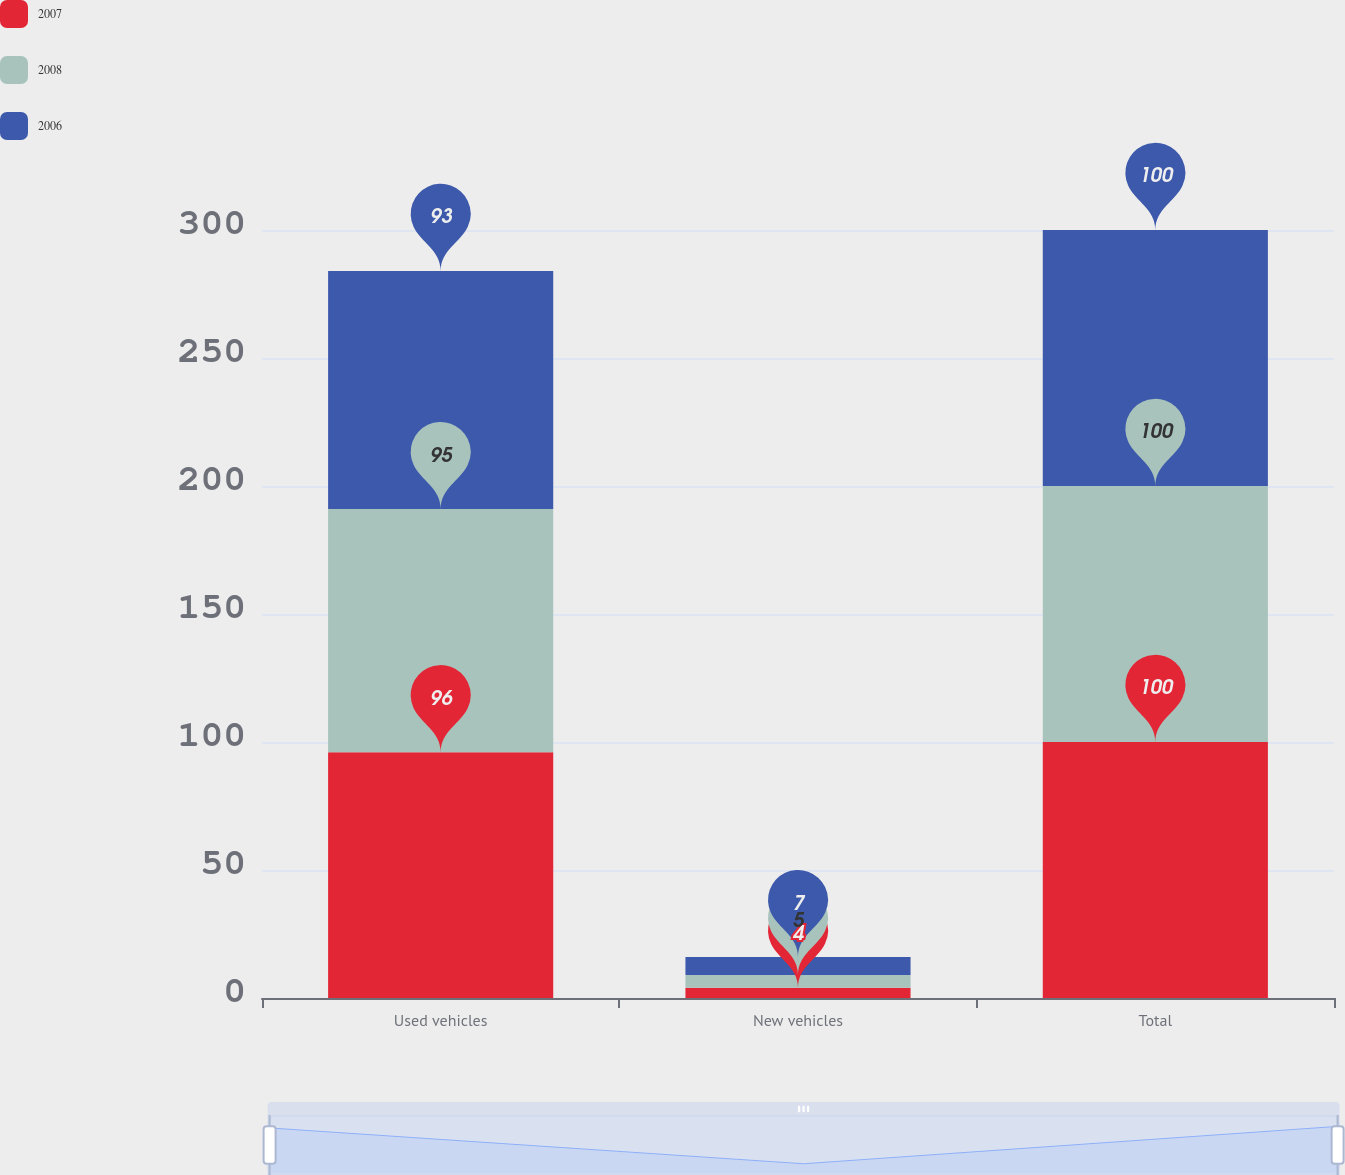Convert chart. <chart><loc_0><loc_0><loc_500><loc_500><stacked_bar_chart><ecel><fcel>Used vehicles<fcel>New vehicles<fcel>Total<nl><fcel>2007<fcel>96<fcel>4<fcel>100<nl><fcel>2008<fcel>95<fcel>5<fcel>100<nl><fcel>2006<fcel>93<fcel>7<fcel>100<nl></chart> 